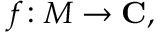Convert formula to latex. <formula><loc_0><loc_0><loc_500><loc_500>f \colon M \to C ,</formula> 